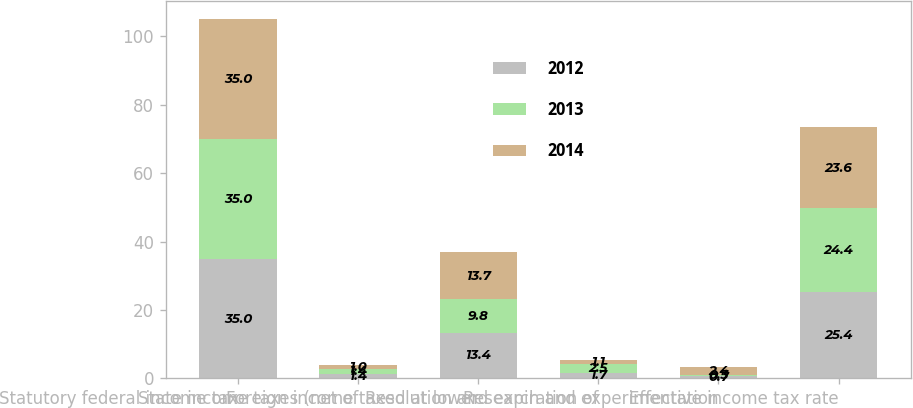Convert chart to OTSL. <chart><loc_0><loc_0><loc_500><loc_500><stacked_bar_chart><ecel><fcel>Statutory federal income tax<fcel>State income taxes (net of<fcel>Foreign income taxed at lower<fcel>Resolution and expiration of<fcel>Research and experimentation<fcel>Effective income tax rate<nl><fcel>2012<fcel>35<fcel>1.4<fcel>13.4<fcel>1.7<fcel>0.7<fcel>25.4<nl><fcel>2013<fcel>35<fcel>1.4<fcel>9.8<fcel>2.5<fcel>0.3<fcel>24.4<nl><fcel>2014<fcel>35<fcel>1<fcel>13.7<fcel>1.1<fcel>2.4<fcel>23.6<nl></chart> 